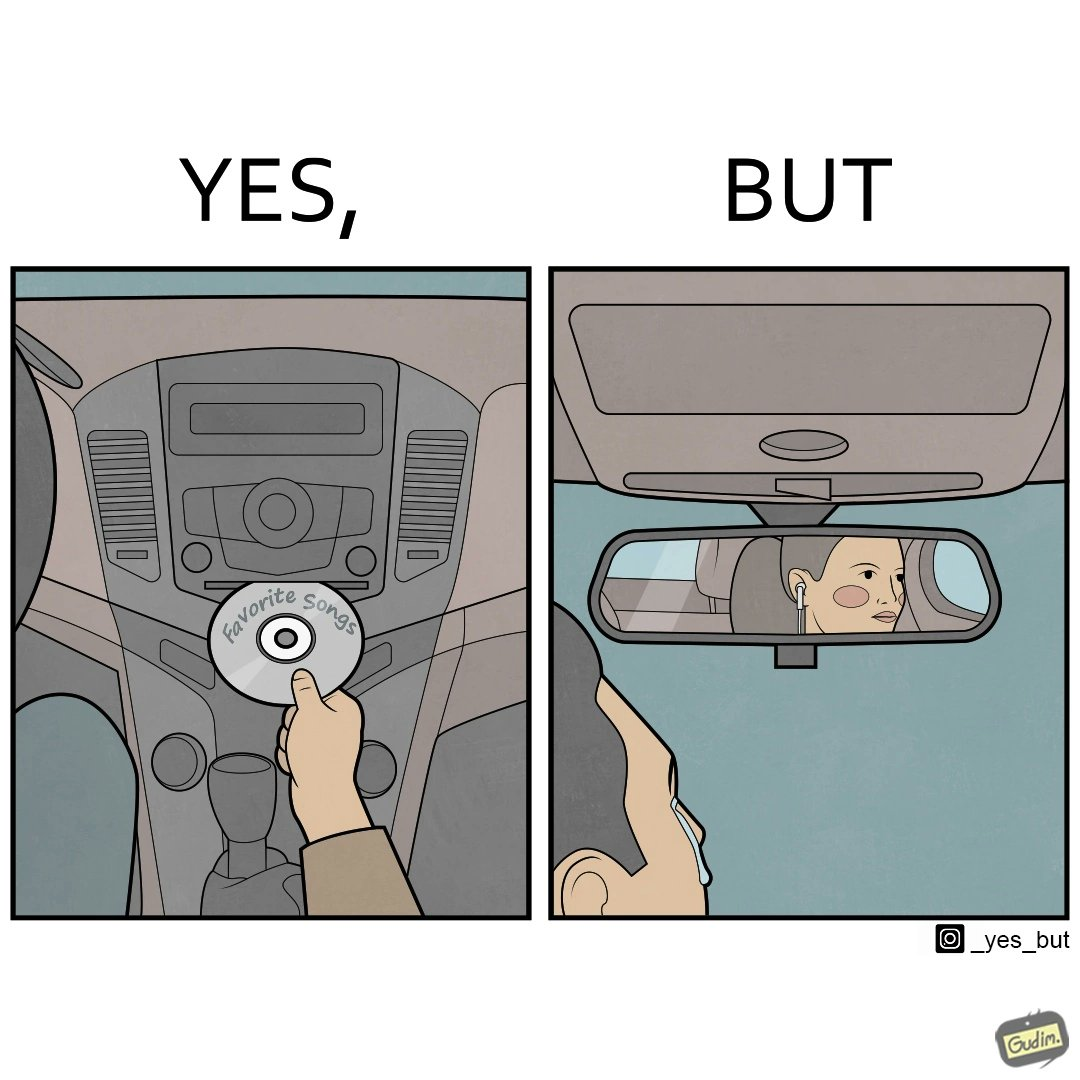Is there satirical content in this image? Yes, this image is satirical. 